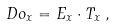<formula> <loc_0><loc_0><loc_500><loc_500>\ D o _ { x } = E _ { x } \cdot T _ { x } \, ,</formula> 